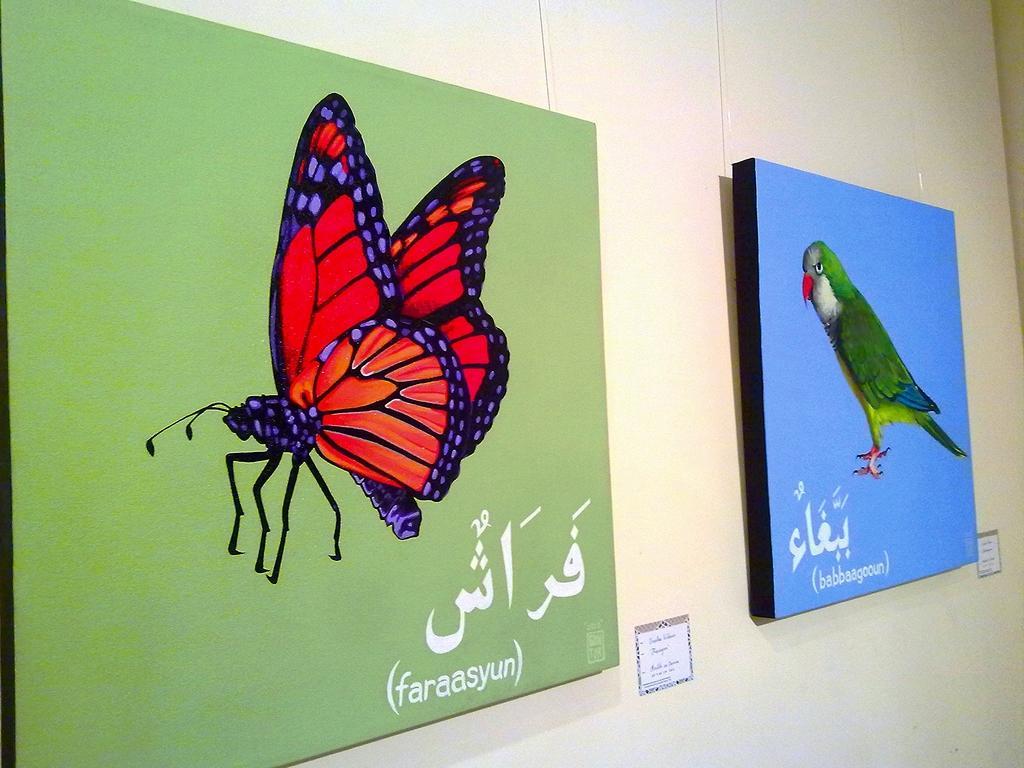Please provide a concise description of this image. In this image we can see photo frames on the wall. On the photo frames we can see butterfly, parrot and text. 